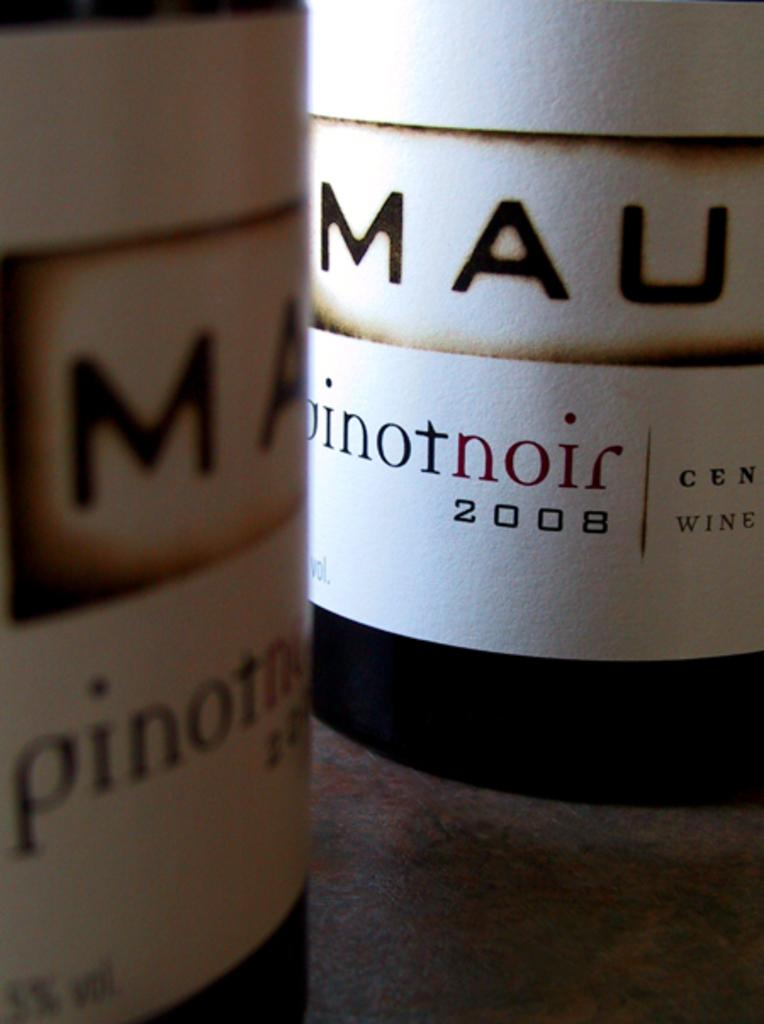<image>
Provide a brief description of the given image. A bottle of pinot noir from 2008 sits close to another bottle. 